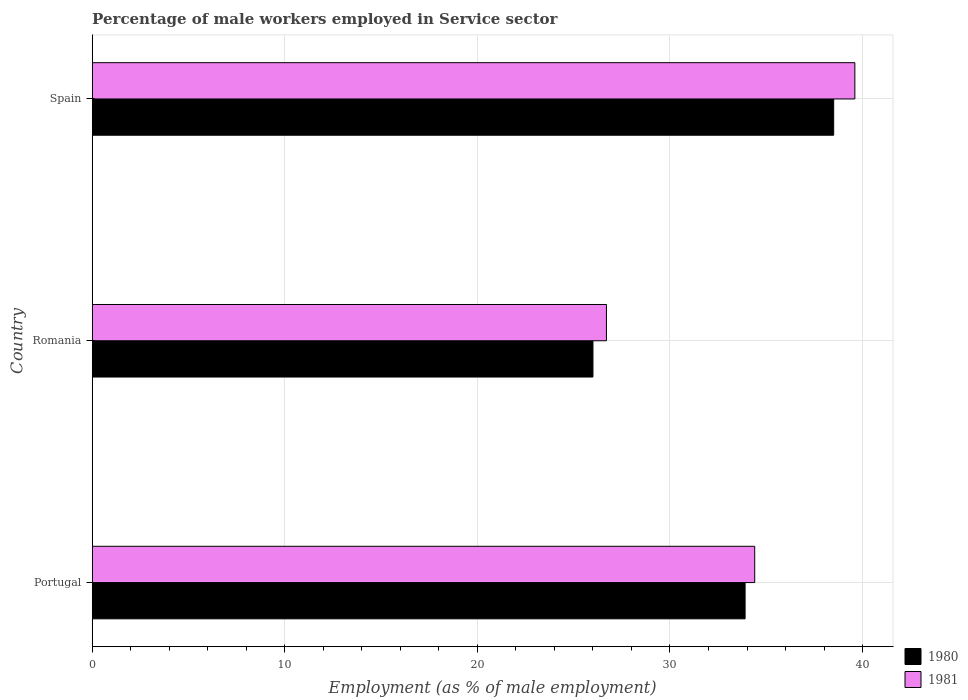How many groups of bars are there?
Provide a succinct answer. 3. Are the number of bars on each tick of the Y-axis equal?
Offer a very short reply. Yes. How many bars are there on the 2nd tick from the top?
Your answer should be very brief. 2. In how many cases, is the number of bars for a given country not equal to the number of legend labels?
Your answer should be compact. 0. What is the percentage of male workers employed in Service sector in 1980 in Spain?
Offer a terse response. 38.5. Across all countries, what is the maximum percentage of male workers employed in Service sector in 1981?
Offer a terse response. 39.6. In which country was the percentage of male workers employed in Service sector in 1980 maximum?
Your answer should be compact. Spain. In which country was the percentage of male workers employed in Service sector in 1980 minimum?
Provide a short and direct response. Romania. What is the total percentage of male workers employed in Service sector in 1981 in the graph?
Offer a very short reply. 100.7. What is the difference between the percentage of male workers employed in Service sector in 1980 in Portugal and that in Romania?
Offer a very short reply. 7.9. What is the difference between the percentage of male workers employed in Service sector in 1980 in Portugal and the percentage of male workers employed in Service sector in 1981 in Romania?
Your response must be concise. 7.2. What is the average percentage of male workers employed in Service sector in 1980 per country?
Keep it short and to the point. 32.8. What is the difference between the percentage of male workers employed in Service sector in 1981 and percentage of male workers employed in Service sector in 1980 in Spain?
Make the answer very short. 1.1. In how many countries, is the percentage of male workers employed in Service sector in 1980 greater than 8 %?
Make the answer very short. 3. What is the ratio of the percentage of male workers employed in Service sector in 1981 in Portugal to that in Spain?
Your answer should be very brief. 0.87. Is the percentage of male workers employed in Service sector in 1981 in Portugal less than that in Spain?
Ensure brevity in your answer.  Yes. What is the difference between the highest and the second highest percentage of male workers employed in Service sector in 1980?
Provide a short and direct response. 4.6. What is the difference between the highest and the lowest percentage of male workers employed in Service sector in 1981?
Provide a succinct answer. 12.9. In how many countries, is the percentage of male workers employed in Service sector in 1981 greater than the average percentage of male workers employed in Service sector in 1981 taken over all countries?
Your answer should be very brief. 2. Is the sum of the percentage of male workers employed in Service sector in 1980 in Romania and Spain greater than the maximum percentage of male workers employed in Service sector in 1981 across all countries?
Ensure brevity in your answer.  Yes. What does the 1st bar from the bottom in Portugal represents?
Give a very brief answer. 1980. How many bars are there?
Give a very brief answer. 6. Are all the bars in the graph horizontal?
Offer a terse response. Yes. Are the values on the major ticks of X-axis written in scientific E-notation?
Keep it short and to the point. No. Does the graph contain grids?
Your response must be concise. Yes. Where does the legend appear in the graph?
Provide a succinct answer. Bottom right. How are the legend labels stacked?
Make the answer very short. Vertical. What is the title of the graph?
Make the answer very short. Percentage of male workers employed in Service sector. What is the label or title of the X-axis?
Give a very brief answer. Employment (as % of male employment). What is the Employment (as % of male employment) in 1980 in Portugal?
Your answer should be very brief. 33.9. What is the Employment (as % of male employment) of 1981 in Portugal?
Keep it short and to the point. 34.4. What is the Employment (as % of male employment) of 1980 in Romania?
Provide a succinct answer. 26. What is the Employment (as % of male employment) of 1981 in Romania?
Offer a very short reply. 26.7. What is the Employment (as % of male employment) of 1980 in Spain?
Your response must be concise. 38.5. What is the Employment (as % of male employment) of 1981 in Spain?
Make the answer very short. 39.6. Across all countries, what is the maximum Employment (as % of male employment) of 1980?
Provide a succinct answer. 38.5. Across all countries, what is the maximum Employment (as % of male employment) in 1981?
Keep it short and to the point. 39.6. Across all countries, what is the minimum Employment (as % of male employment) of 1980?
Your answer should be very brief. 26. Across all countries, what is the minimum Employment (as % of male employment) of 1981?
Give a very brief answer. 26.7. What is the total Employment (as % of male employment) in 1980 in the graph?
Offer a terse response. 98.4. What is the total Employment (as % of male employment) of 1981 in the graph?
Provide a succinct answer. 100.7. What is the difference between the Employment (as % of male employment) in 1980 in Portugal and that in Romania?
Provide a succinct answer. 7.9. What is the difference between the Employment (as % of male employment) in 1981 in Portugal and that in Romania?
Give a very brief answer. 7.7. What is the difference between the Employment (as % of male employment) of 1980 in Romania and that in Spain?
Your response must be concise. -12.5. What is the difference between the Employment (as % of male employment) in 1981 in Romania and that in Spain?
Your answer should be compact. -12.9. What is the difference between the Employment (as % of male employment) in 1980 in Portugal and the Employment (as % of male employment) in 1981 in Spain?
Your response must be concise. -5.7. What is the average Employment (as % of male employment) of 1980 per country?
Keep it short and to the point. 32.8. What is the average Employment (as % of male employment) in 1981 per country?
Offer a terse response. 33.57. What is the difference between the Employment (as % of male employment) of 1980 and Employment (as % of male employment) of 1981 in Romania?
Your response must be concise. -0.7. What is the difference between the Employment (as % of male employment) in 1980 and Employment (as % of male employment) in 1981 in Spain?
Provide a short and direct response. -1.1. What is the ratio of the Employment (as % of male employment) in 1980 in Portugal to that in Romania?
Provide a short and direct response. 1.3. What is the ratio of the Employment (as % of male employment) in 1981 in Portugal to that in Romania?
Your answer should be compact. 1.29. What is the ratio of the Employment (as % of male employment) of 1980 in Portugal to that in Spain?
Your response must be concise. 0.88. What is the ratio of the Employment (as % of male employment) in 1981 in Portugal to that in Spain?
Make the answer very short. 0.87. What is the ratio of the Employment (as % of male employment) of 1980 in Romania to that in Spain?
Keep it short and to the point. 0.68. What is the ratio of the Employment (as % of male employment) of 1981 in Romania to that in Spain?
Make the answer very short. 0.67. What is the difference between the highest and the lowest Employment (as % of male employment) in 1980?
Give a very brief answer. 12.5. What is the difference between the highest and the lowest Employment (as % of male employment) in 1981?
Provide a succinct answer. 12.9. 